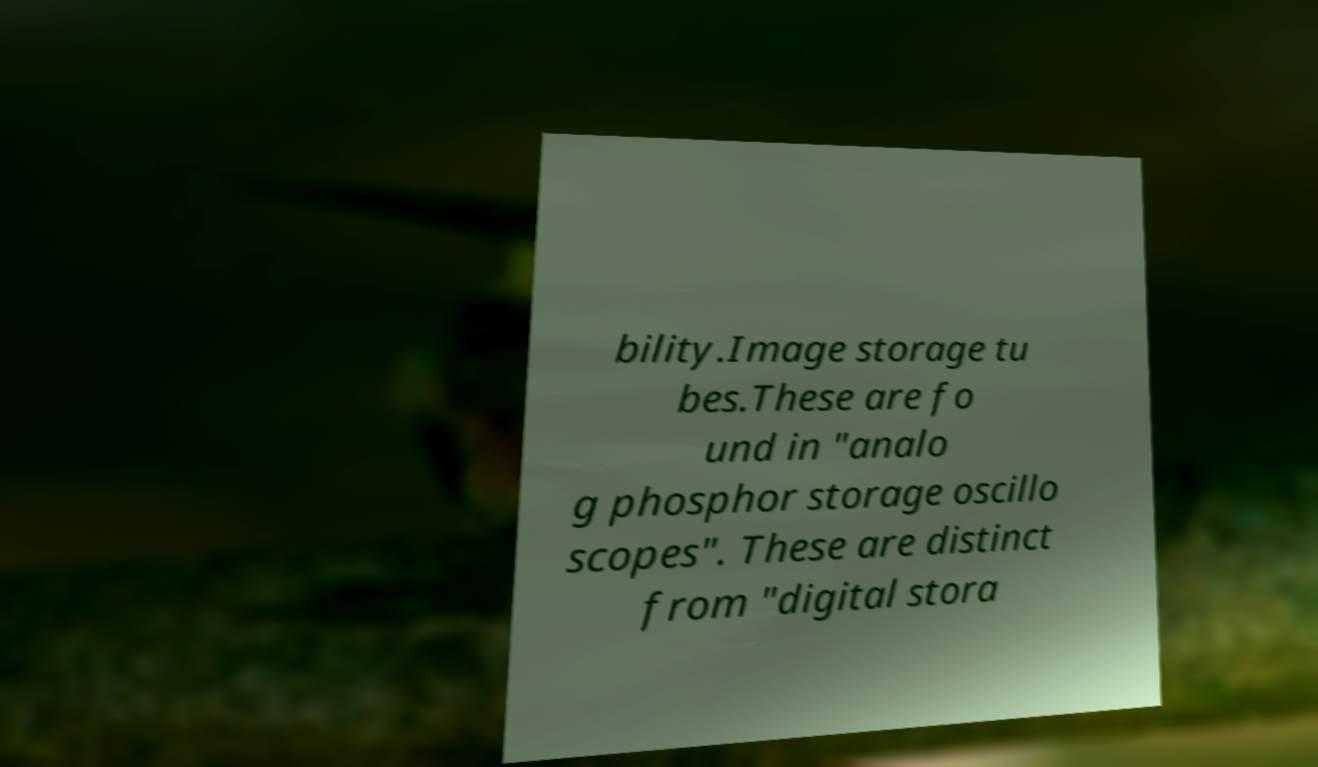For documentation purposes, I need the text within this image transcribed. Could you provide that? bility.Image storage tu bes.These are fo und in "analo g phosphor storage oscillo scopes". These are distinct from "digital stora 